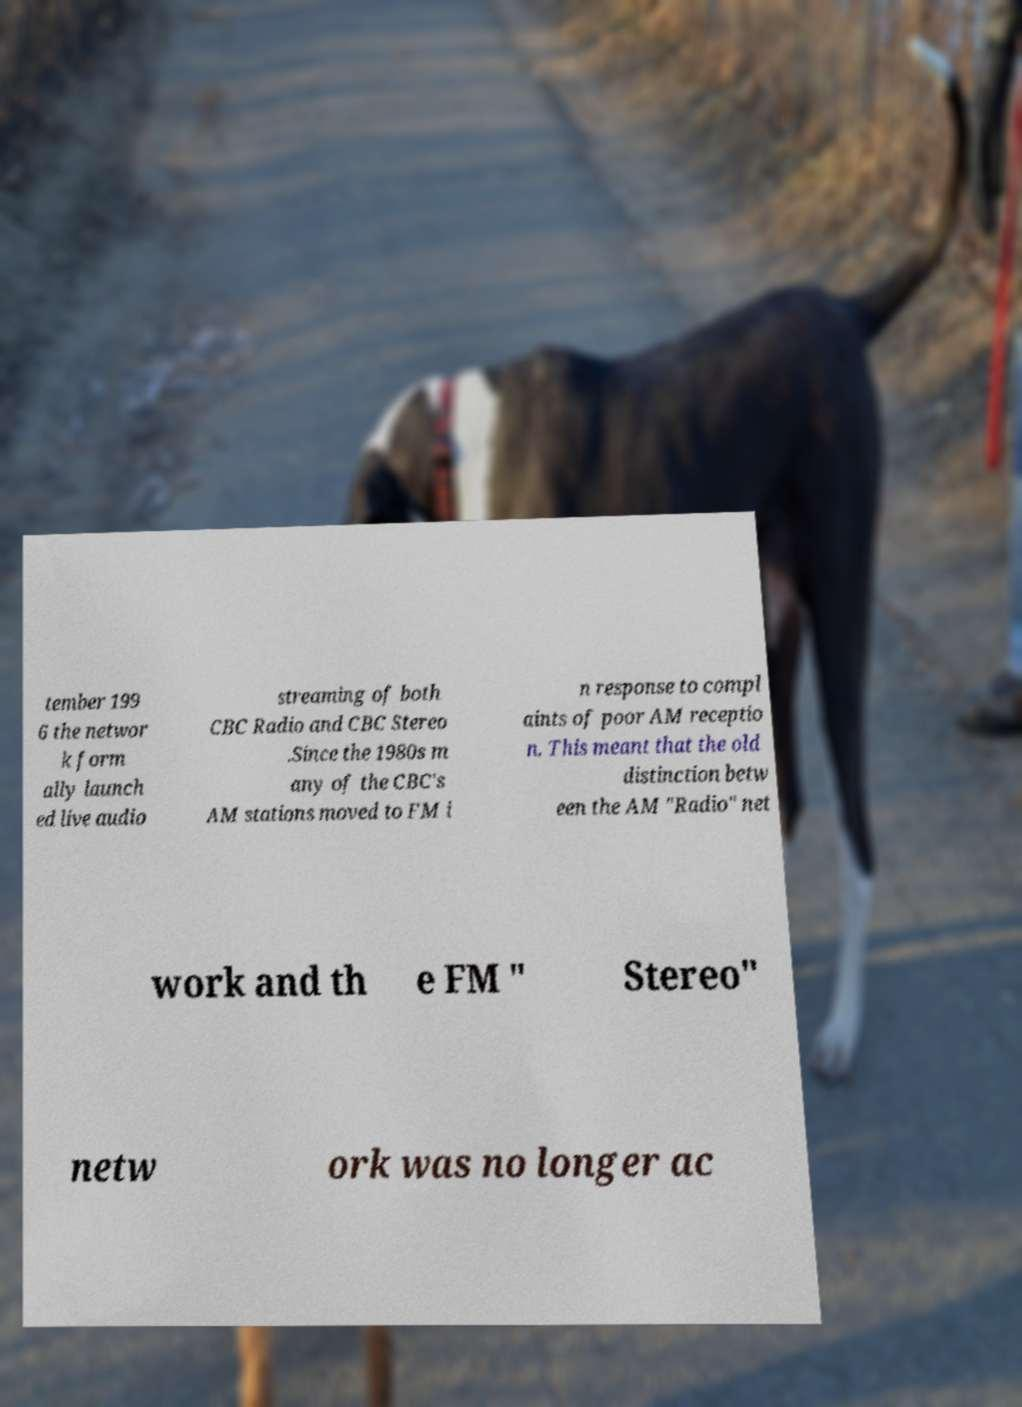Please identify and transcribe the text found in this image. tember 199 6 the networ k form ally launch ed live audio streaming of both CBC Radio and CBC Stereo .Since the 1980s m any of the CBC's AM stations moved to FM i n response to compl aints of poor AM receptio n. This meant that the old distinction betw een the AM "Radio" net work and th e FM " Stereo" netw ork was no longer ac 